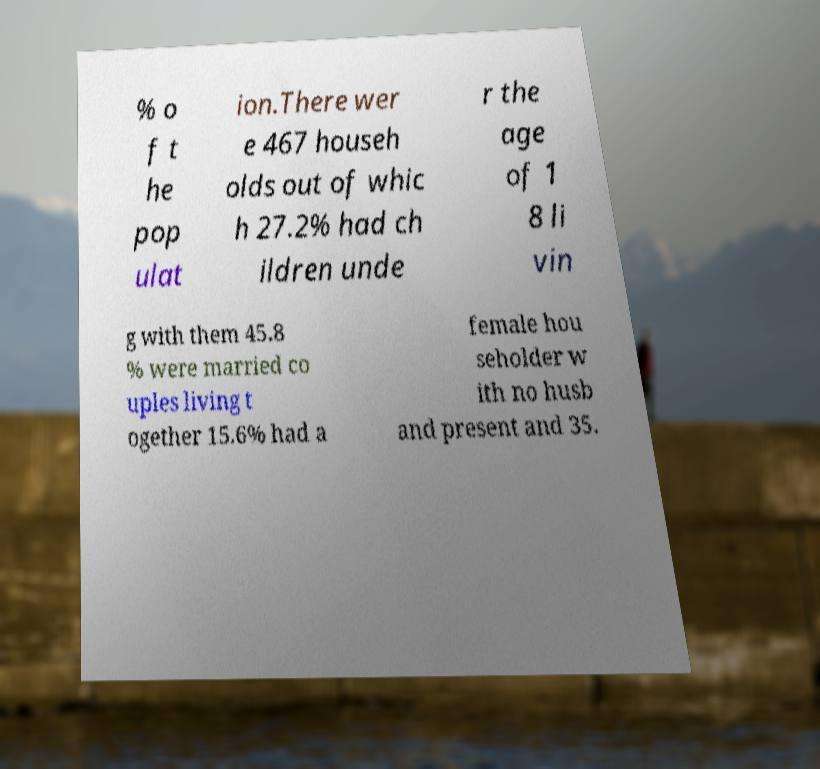There's text embedded in this image that I need extracted. Can you transcribe it verbatim? % o f t he pop ulat ion.There wer e 467 househ olds out of whic h 27.2% had ch ildren unde r the age of 1 8 li vin g with them 45.8 % were married co uples living t ogether 15.6% had a female hou seholder w ith no husb and present and 35. 